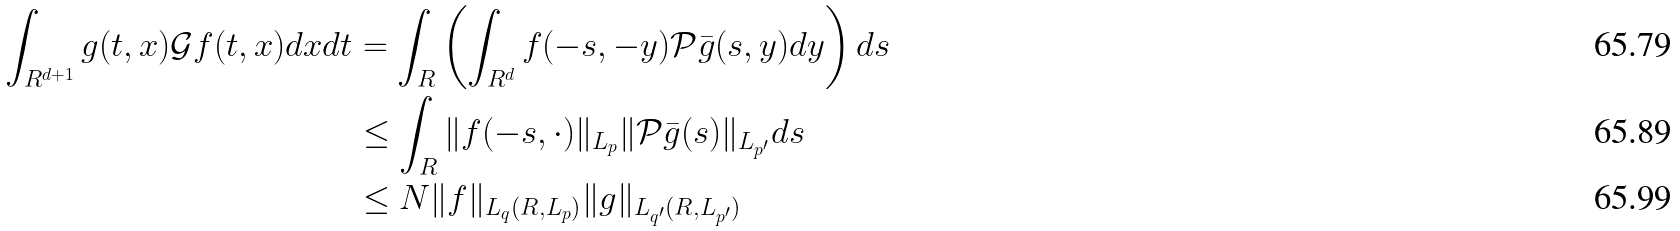Convert formula to latex. <formula><loc_0><loc_0><loc_500><loc_500>\int _ { R ^ { d + 1 } } g ( t , x ) \mathcal { G } f ( t , x ) d x d t & = \int _ { R } \left ( \int _ { R ^ { d } } f ( - s , - y ) \mathcal { P } \bar { g } ( s , y ) d y \right ) d s \\ & \leq \int _ { R } \| f ( - s , \cdot ) \| _ { L _ { p } } \| \mathcal { P } \bar { g } ( s ) \| _ { L _ { p ^ { \prime } } } d s \\ & \leq N \| f \| _ { L _ { q } ( R , L _ { p } ) } \| g \| _ { L _ { q ^ { \prime } } ( R , L _ { p ^ { \prime } } ) }</formula> 